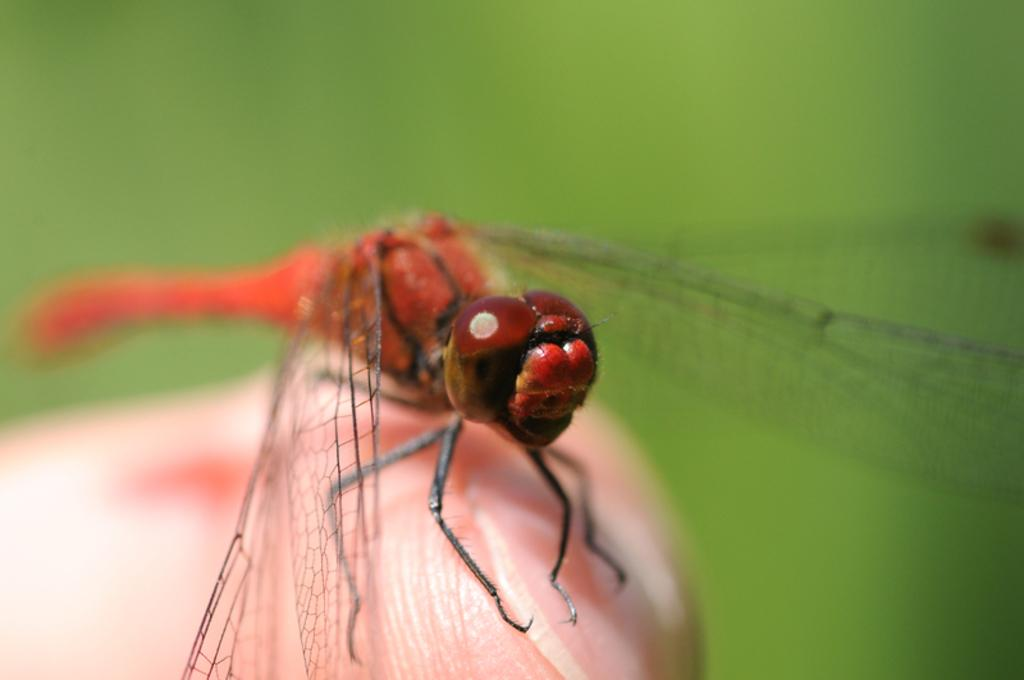What type of creature is present in the image? There is an insect in the image. Where is the insect located in the image? The insect is on the finger of a person. How many strangers are present in the image? There is no stranger present in the image; it only features an insect on a person's finger. What type of flock can be seen flying in the image? There is no flock present in the image. 